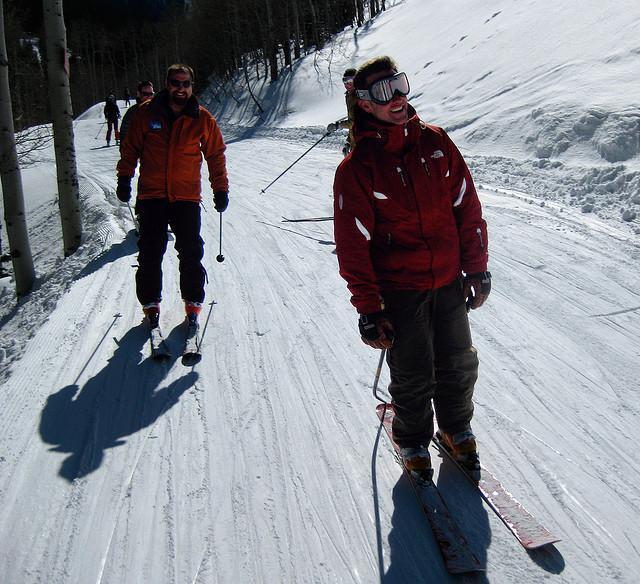How many people are there?
Give a very brief answer. 2. How many brown cows are there on the beach?
Give a very brief answer. 0. 